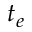Convert formula to latex. <formula><loc_0><loc_0><loc_500><loc_500>t _ { e }</formula> 